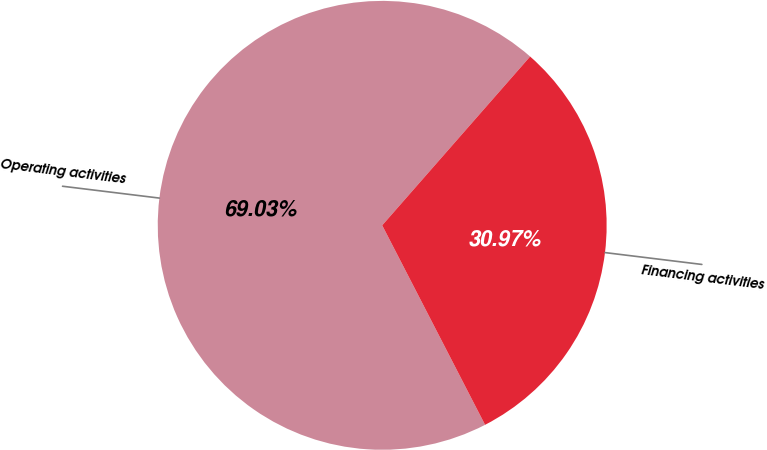<chart> <loc_0><loc_0><loc_500><loc_500><pie_chart><fcel>Operating activities<fcel>Financing activities<nl><fcel>69.03%<fcel>30.97%<nl></chart> 